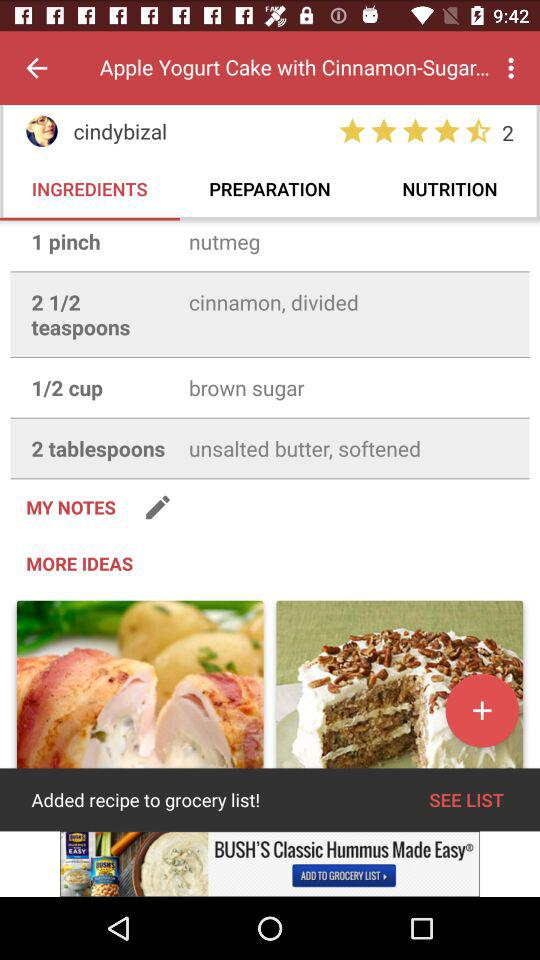How many teaspoons of "cinnamon" are needed in the recipe posted by "cindybizal"? There are "two and half" teaspoons of "cinnamon" needed in the recipe posted by "cindybizal". 